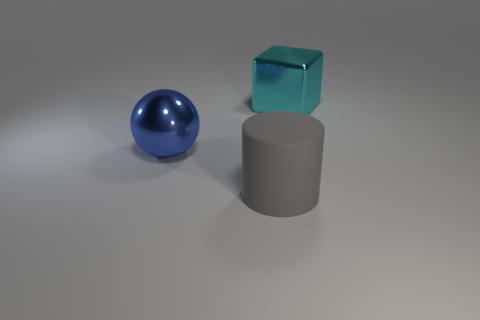Subtract all cylinders. How many objects are left? 2 Add 1 cyan blocks. How many objects exist? 4 Subtract 1 blue spheres. How many objects are left? 2 Subtract 1 cylinders. How many cylinders are left? 0 Subtract all green blocks. How many red spheres are left? 0 Subtract all blue metallic objects. Subtract all tiny blue matte objects. How many objects are left? 2 Add 1 cyan metallic blocks. How many cyan metallic blocks are left? 2 Add 1 large gray things. How many large gray things exist? 2 